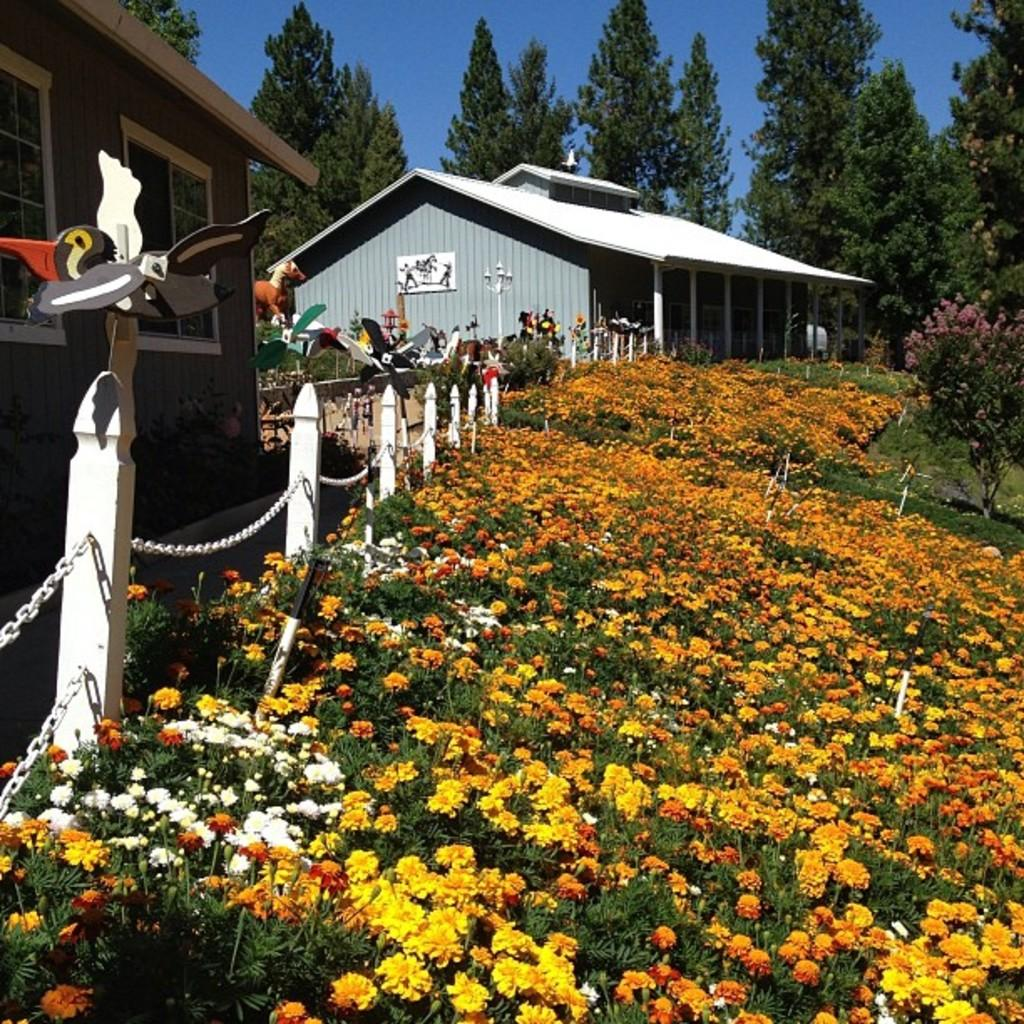What type of plants can be seen in the image? There are flowers in the image. What type of structures are present in the image? There are houses in the image. What can be seen in the background of the image? There are trees and the sky visible in the background of the image. What type of trousers are the flowers wearing in the image? There are no trousers present in the image, as flowers are plants and do not wear clothing. 